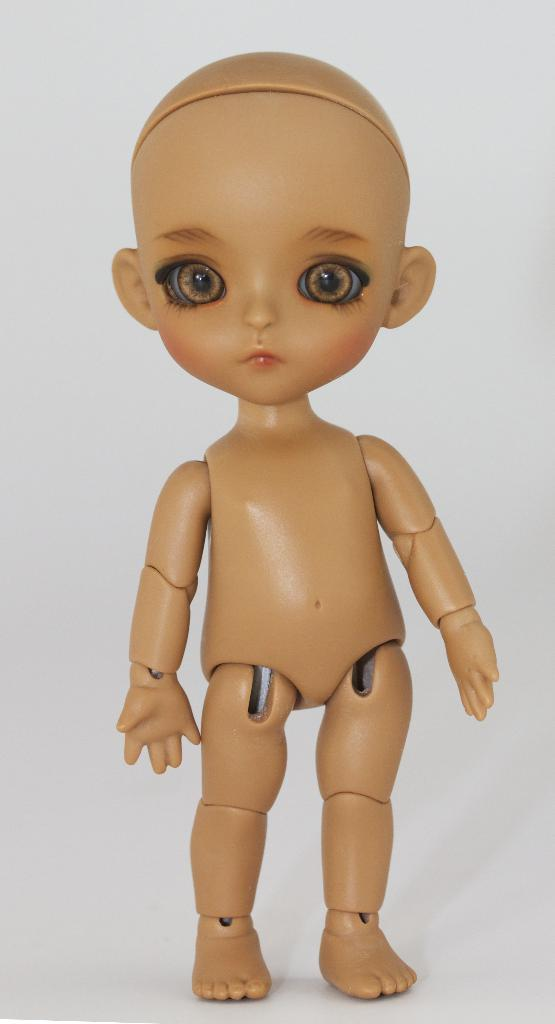What type of toy can be seen in the image? There is a cream-colored toy in the image. What color is the background of the image? The background of the image is white. How many lizards can be seen crawling on the toy in the image? There are no lizards present in the image. What thrilling activity is taking place in the image? There is no thrilling activity depicted in the image; it simply a cream-colored toy against a white background. 